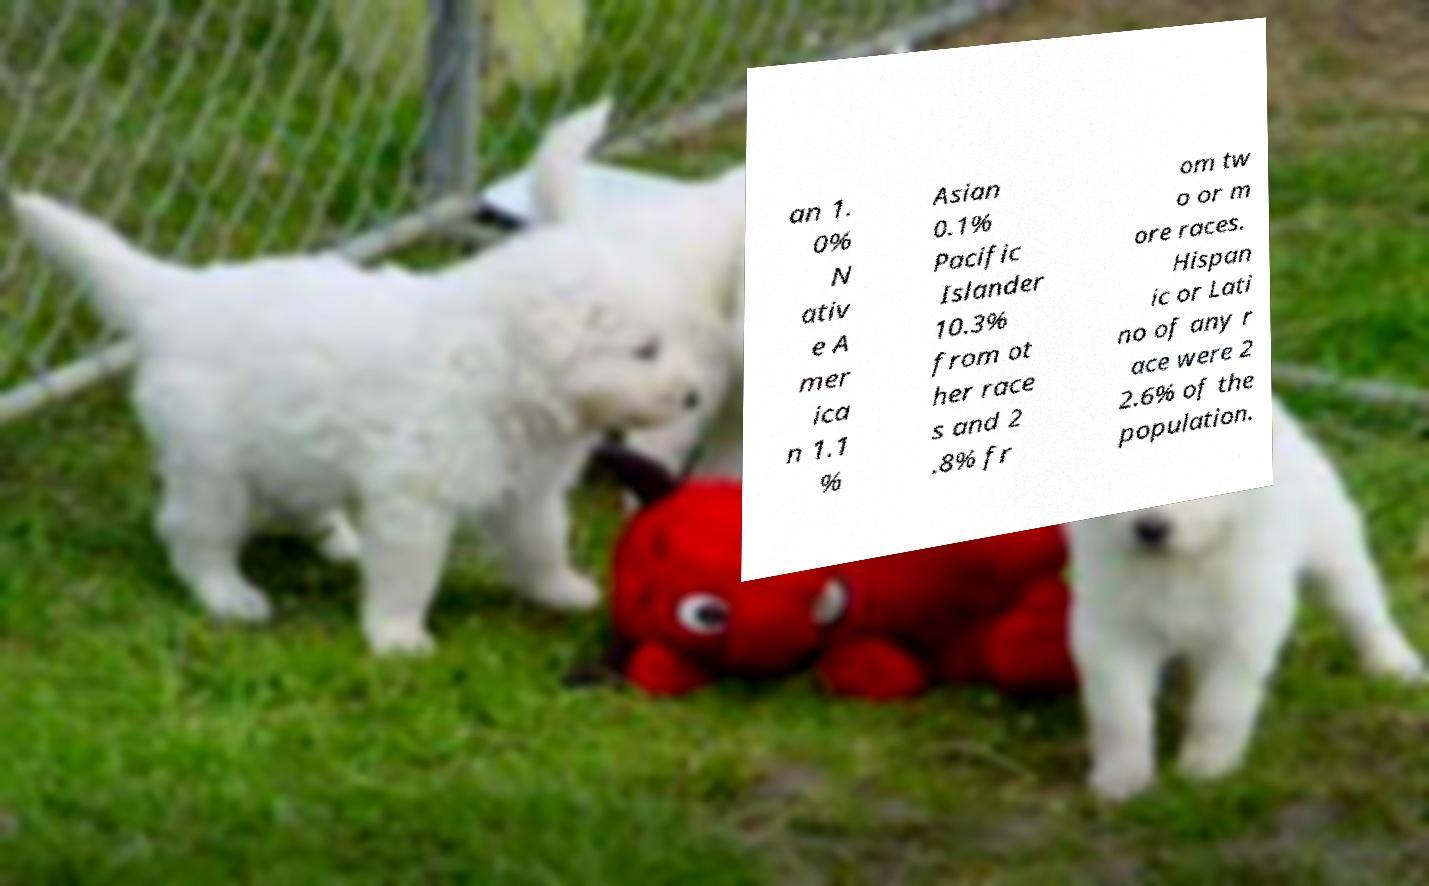What messages or text are displayed in this image? I need them in a readable, typed format. an 1. 0% N ativ e A mer ica n 1.1 % Asian 0.1% Pacific Islander 10.3% from ot her race s and 2 .8% fr om tw o or m ore races. Hispan ic or Lati no of any r ace were 2 2.6% of the population. 